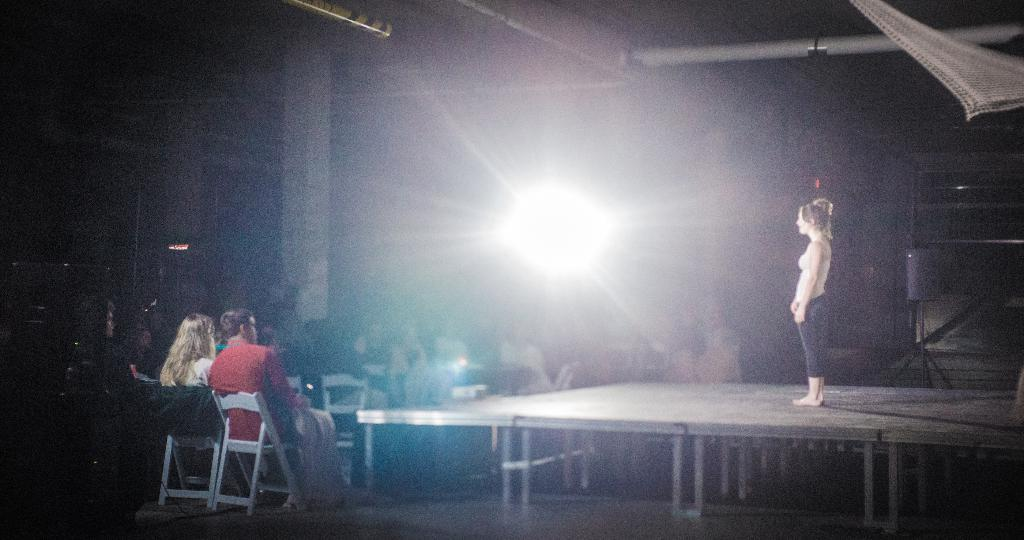What type of structure can be seen in the image? There is a wall in the image. What can be used for illumination in the image? There is a light in the image. What are the people in the image doing? There are people sitting on chairs in the image. What is the primary feature of the stage in the image? There is a stage in the image. Can you see a stream of water flowing through the image? There is no stream of water present in the image. What type of wire is being used by the people sitting on chairs? There is no wire visible in the image; the people are simply sitting on chairs. 